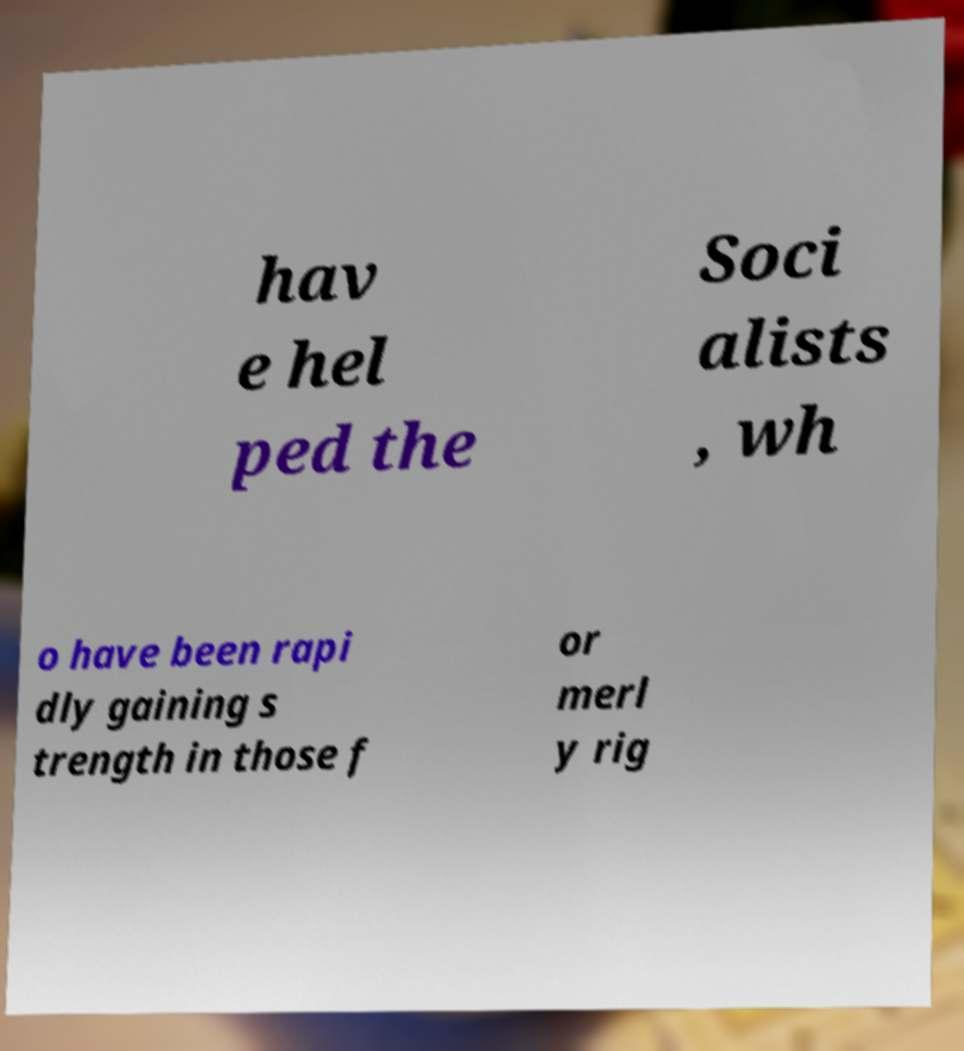There's text embedded in this image that I need extracted. Can you transcribe it verbatim? hav e hel ped the Soci alists , wh o have been rapi dly gaining s trength in those f or merl y rig 